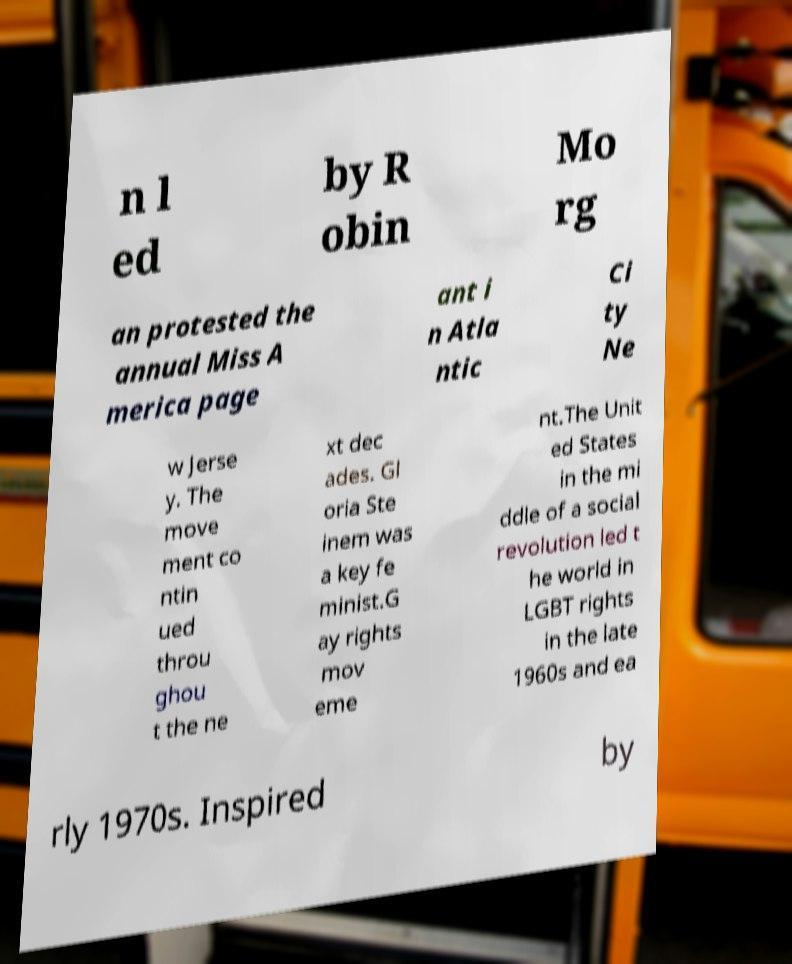Please read and relay the text visible in this image. What does it say? n l ed by R obin Mo rg an protested the annual Miss A merica page ant i n Atla ntic Ci ty Ne w Jerse y. The move ment co ntin ued throu ghou t the ne xt dec ades. Gl oria Ste inem was a key fe minist.G ay rights mov eme nt.The Unit ed States in the mi ddle of a social revolution led t he world in LGBT rights in the late 1960s and ea rly 1970s. Inspired by 